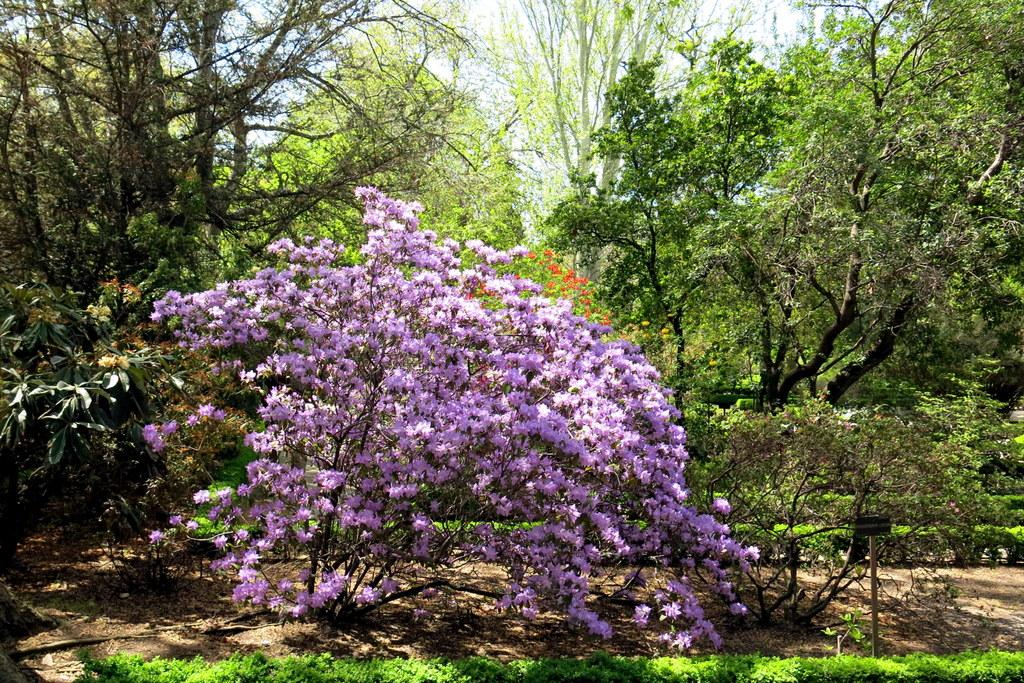What type of vegetation is present on the ground in the image? There is grass on the ground in the image. What can be seen in the background of the image? There are trees, flowers, and the sky visible in the background of the image. What is the price of the cap in the image? There is no cap present in the image, so it is not possible to determine its price. 